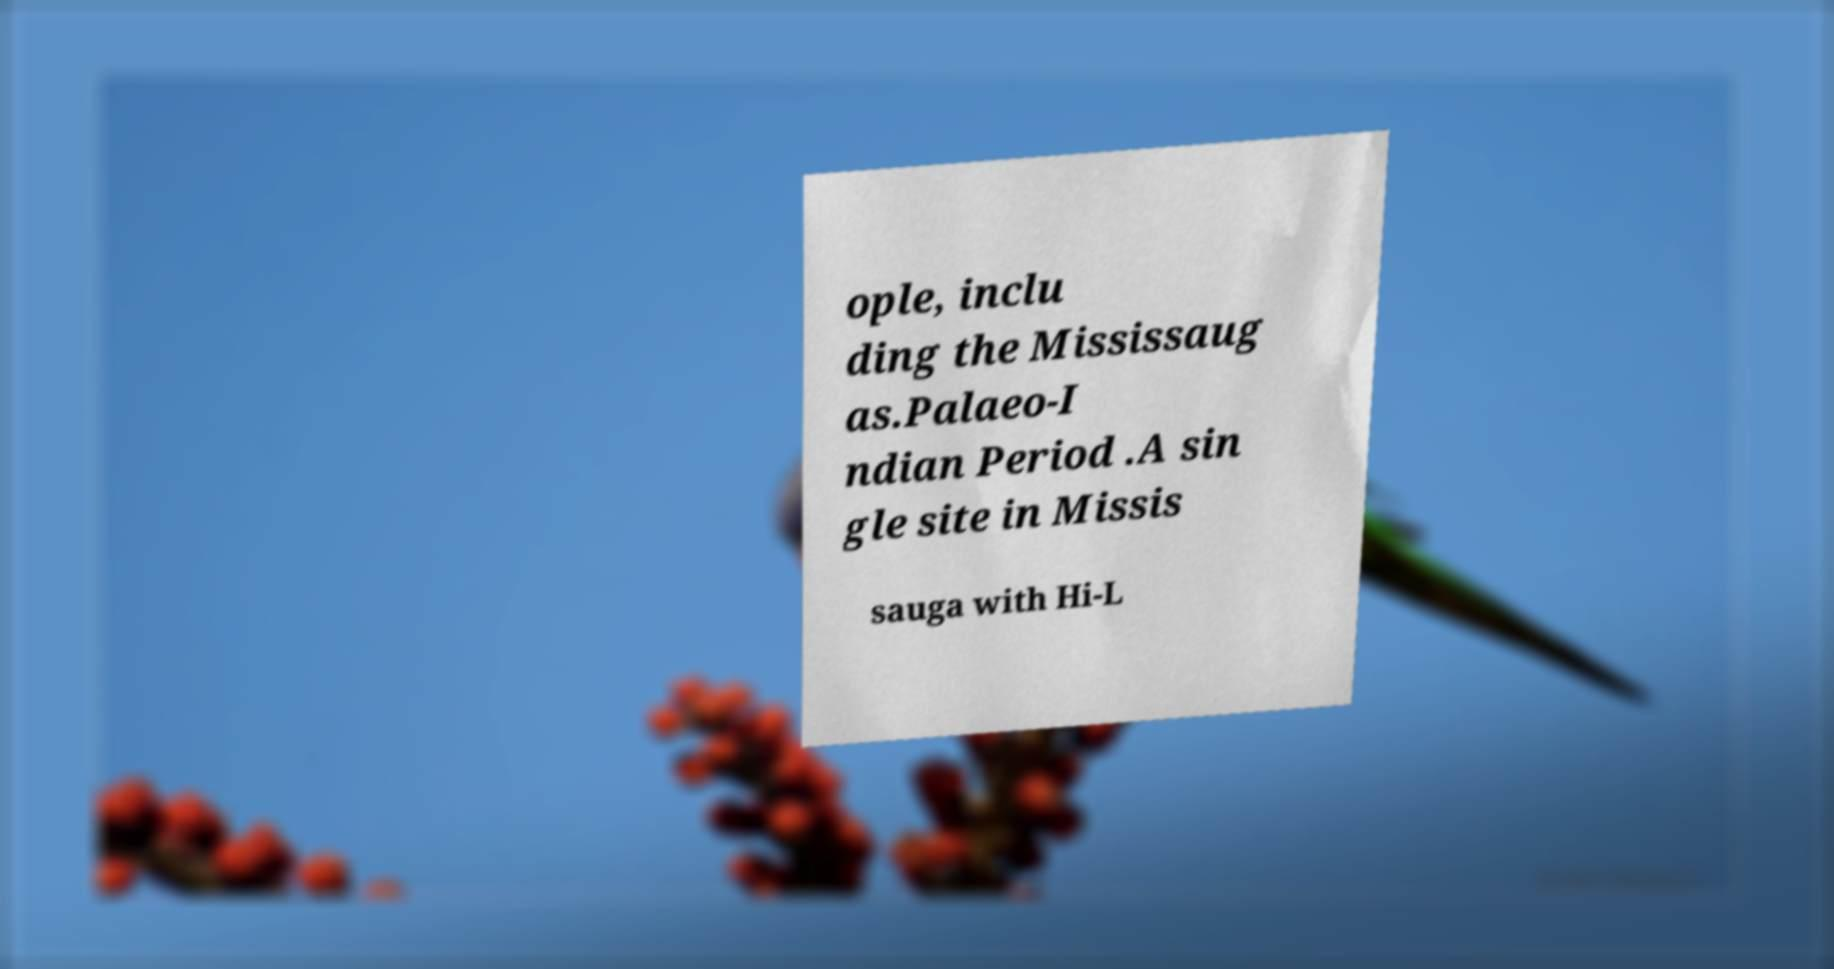I need the written content from this picture converted into text. Can you do that? ople, inclu ding the Mississaug as.Palaeo-I ndian Period .A sin gle site in Missis sauga with Hi-L 